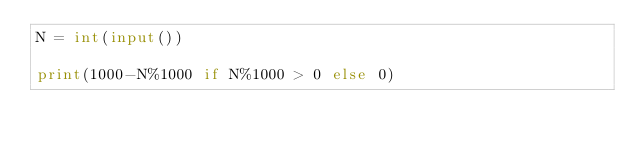Convert code to text. <code><loc_0><loc_0><loc_500><loc_500><_Python_>N = int(input())

print(1000-N%1000 if N%1000 > 0 else 0)</code> 